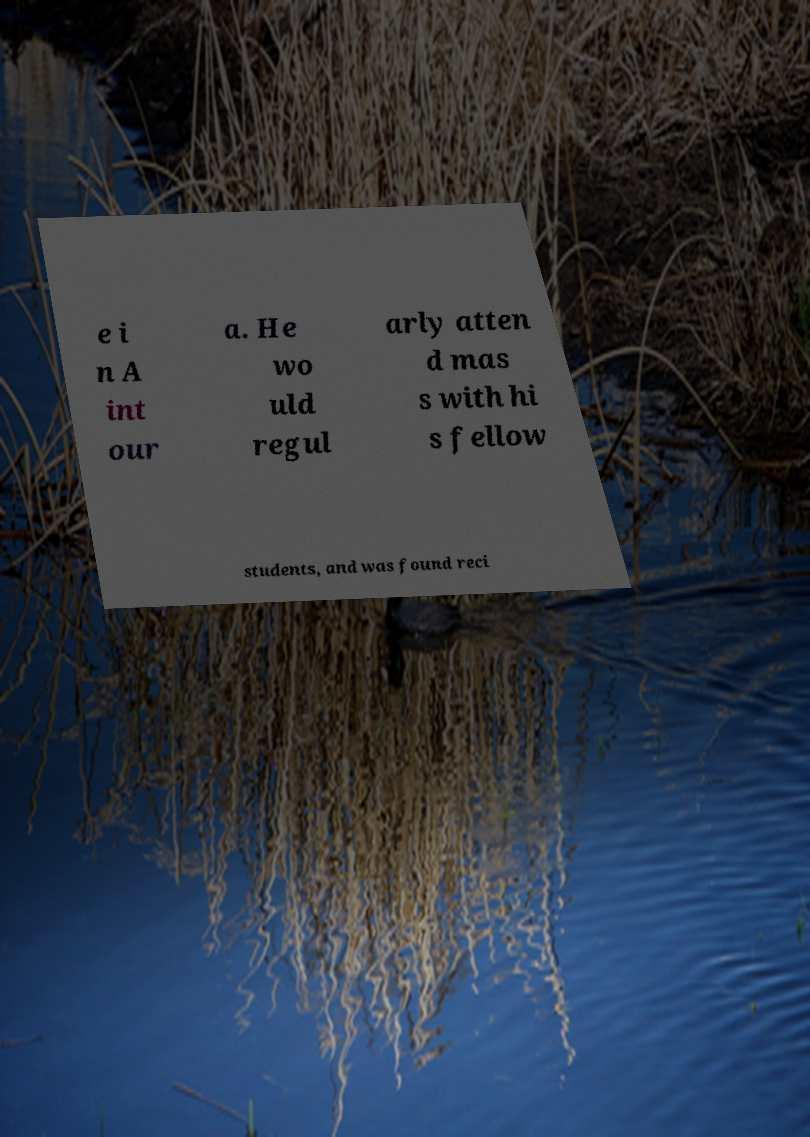Please identify and transcribe the text found in this image. e i n A int our a. He wo uld regul arly atten d mas s with hi s fellow students, and was found reci 